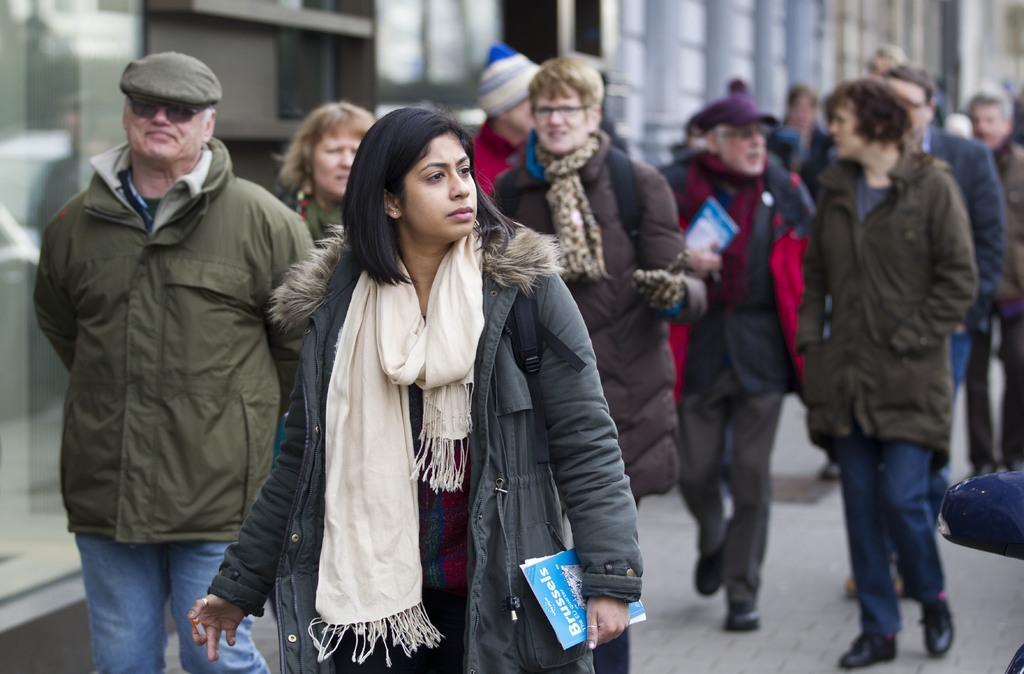What are the people in the image doing? The people in the image are walking on the road. Are the people carrying anything while walking? Yes, some people are holding objects in the image. What can be seen in the background of the image? There are buildings visible in the image. How many lizards can be seen crawling on the buildings in the image? There are no lizards visible in the image; only people walking on the road and buildings can be seen. 